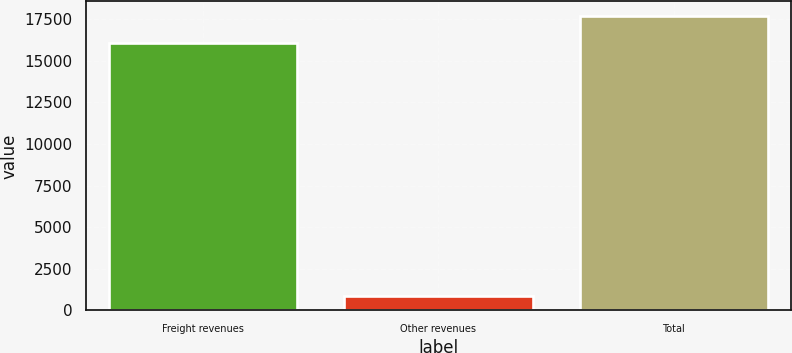Convert chart to OTSL. <chart><loc_0><loc_0><loc_500><loc_500><bar_chart><fcel>Freight revenues<fcel>Other revenues<fcel>Total<nl><fcel>16069<fcel>896<fcel>17675.9<nl></chart> 